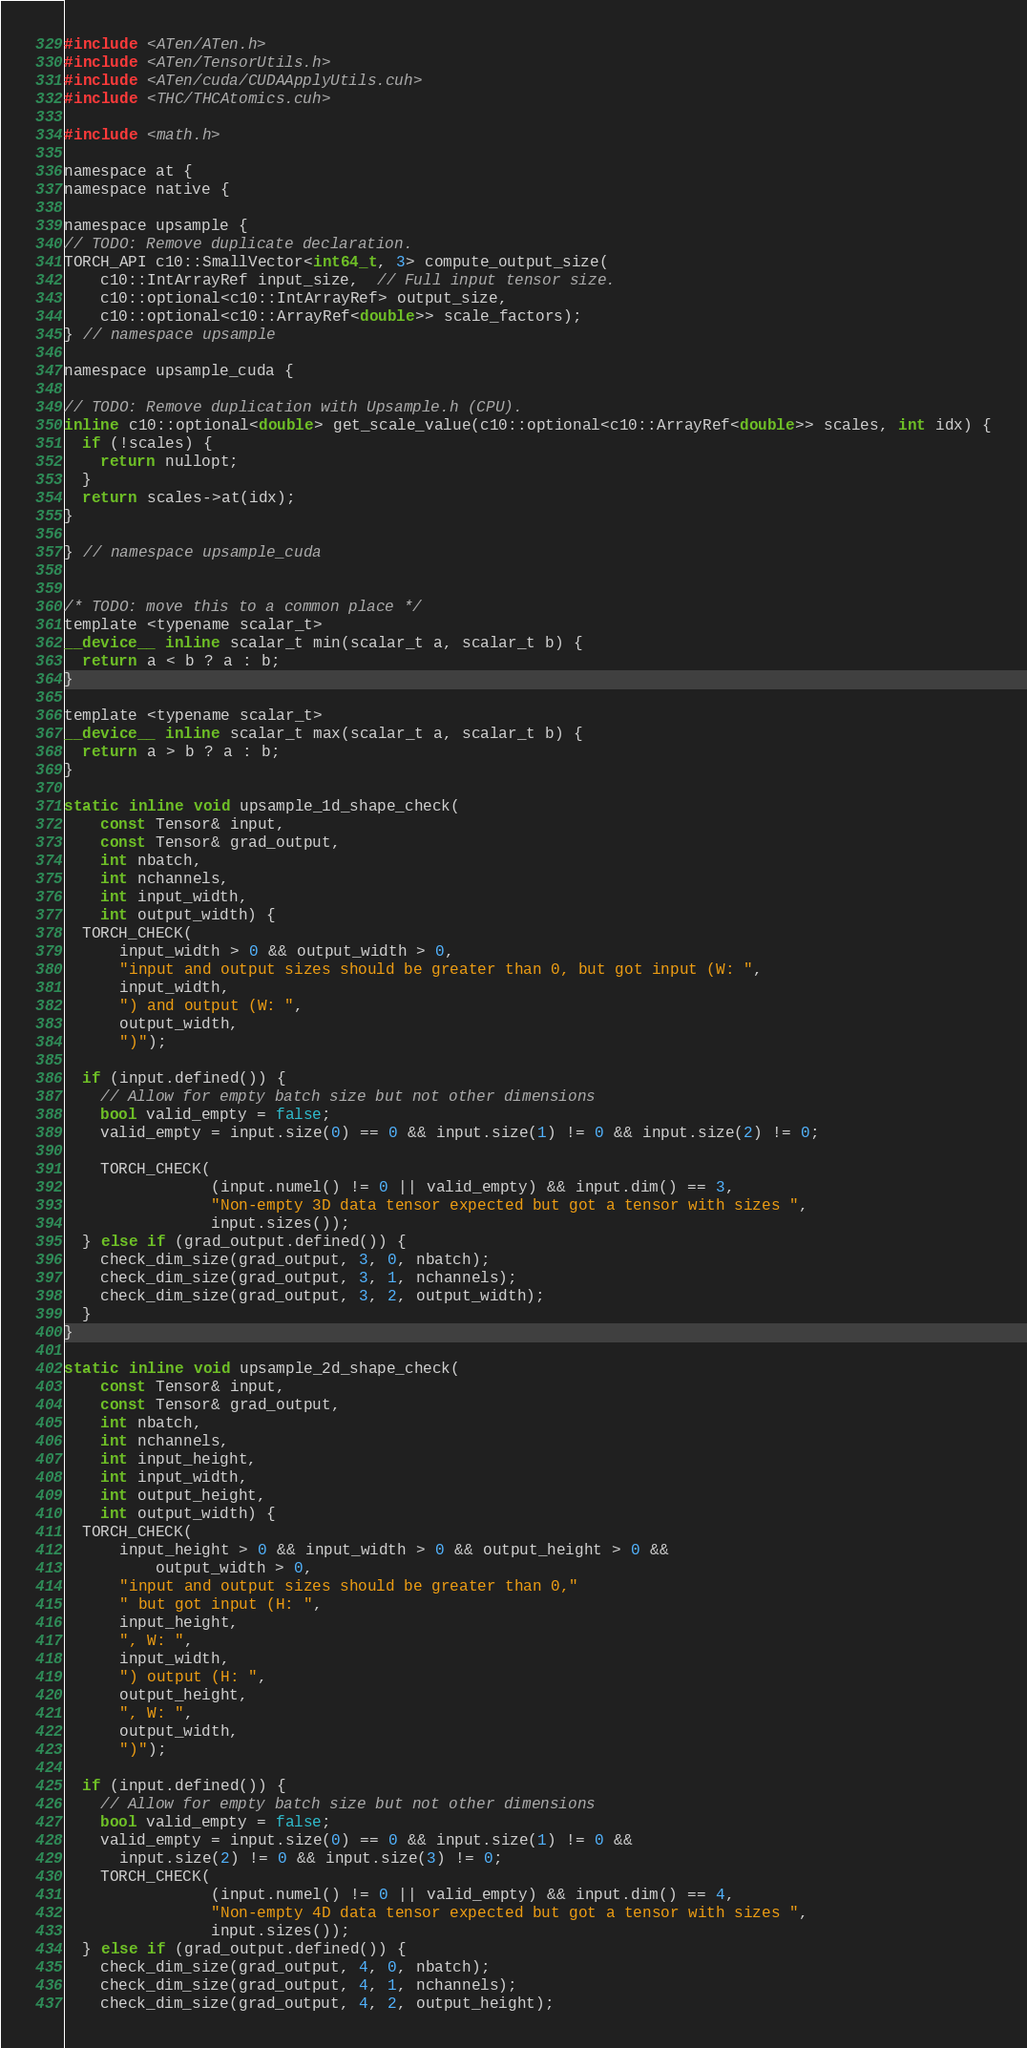<code> <loc_0><loc_0><loc_500><loc_500><_Cuda_>#include <ATen/ATen.h>
#include <ATen/TensorUtils.h>
#include <ATen/cuda/CUDAApplyUtils.cuh>
#include <THC/THCAtomics.cuh>

#include <math.h>

namespace at {
namespace native {

namespace upsample {
// TODO: Remove duplicate declaration.
TORCH_API c10::SmallVector<int64_t, 3> compute_output_size(
    c10::IntArrayRef input_size,  // Full input tensor size.
    c10::optional<c10::IntArrayRef> output_size,
    c10::optional<c10::ArrayRef<double>> scale_factors);
} // namespace upsample

namespace upsample_cuda {

// TODO: Remove duplication with Upsample.h (CPU).
inline c10::optional<double> get_scale_value(c10::optional<c10::ArrayRef<double>> scales, int idx) {
  if (!scales) {
    return nullopt;
  }
  return scales->at(idx);
}

} // namespace upsample_cuda


/* TODO: move this to a common place */
template <typename scalar_t>
__device__ inline scalar_t min(scalar_t a, scalar_t b) {
  return a < b ? a : b;
}

template <typename scalar_t>
__device__ inline scalar_t max(scalar_t a, scalar_t b) {
  return a > b ? a : b;
}

static inline void upsample_1d_shape_check(
    const Tensor& input,
    const Tensor& grad_output,
    int nbatch,
    int nchannels,
    int input_width,
    int output_width) {
  TORCH_CHECK(
      input_width > 0 && output_width > 0,
      "input and output sizes should be greater than 0, but got input (W: ",
      input_width,
      ") and output (W: ",
      output_width,
      ")");

  if (input.defined()) {
    // Allow for empty batch size but not other dimensions
    bool valid_empty = false;
    valid_empty = input.size(0) == 0 && input.size(1) != 0 && input.size(2) != 0;

    TORCH_CHECK(
                (input.numel() != 0 || valid_empty) && input.dim() == 3,
                "Non-empty 3D data tensor expected but got a tensor with sizes ",
                input.sizes());
  } else if (grad_output.defined()) {
    check_dim_size(grad_output, 3, 0, nbatch);
    check_dim_size(grad_output, 3, 1, nchannels);
    check_dim_size(grad_output, 3, 2, output_width);
  }
}

static inline void upsample_2d_shape_check(
    const Tensor& input,
    const Tensor& grad_output,
    int nbatch,
    int nchannels,
    int input_height,
    int input_width,
    int output_height,
    int output_width) {
  TORCH_CHECK(
      input_height > 0 && input_width > 0 && output_height > 0 &&
          output_width > 0,
      "input and output sizes should be greater than 0,"
      " but got input (H: ",
      input_height,
      ", W: ",
      input_width,
      ") output (H: ",
      output_height,
      ", W: ",
      output_width,
      ")");

  if (input.defined()) {
    // Allow for empty batch size but not other dimensions
    bool valid_empty = false;
    valid_empty = input.size(0) == 0 && input.size(1) != 0 &&
      input.size(2) != 0 && input.size(3) != 0;
    TORCH_CHECK(
                (input.numel() != 0 || valid_empty) && input.dim() == 4,
                "Non-empty 4D data tensor expected but got a tensor with sizes ",
                input.sizes());
  } else if (grad_output.defined()) {
    check_dim_size(grad_output, 4, 0, nbatch);
    check_dim_size(grad_output, 4, 1, nchannels);
    check_dim_size(grad_output, 4, 2, output_height);</code> 